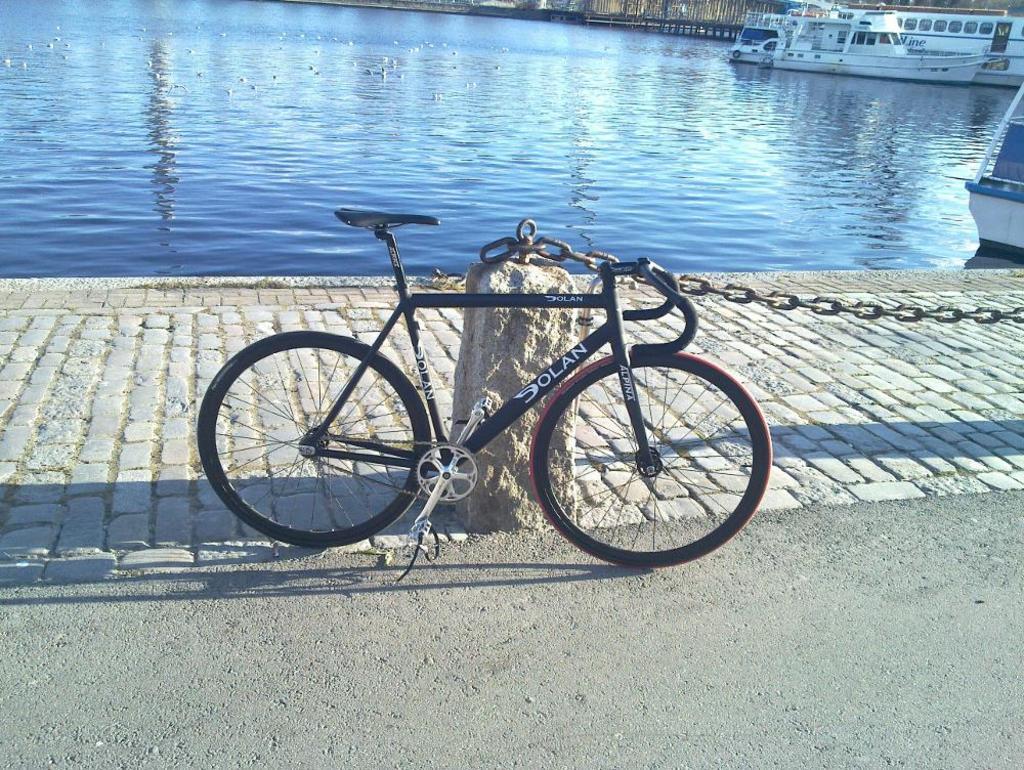How would you summarize this image in a sentence or two? In this image I can see the bicycle which is in black color. To the side I can see the rock and the chain. In the background there are boats on the water. I can see the water in blue color. 